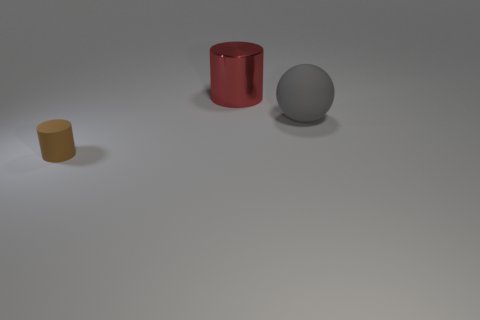Are there any other things that have the same size as the matte cylinder?
Ensure brevity in your answer.  No. There is a cylinder behind the matte cylinder; is its size the same as the tiny thing?
Ensure brevity in your answer.  No. There is a thing that is to the left of the large gray thing and right of the small brown thing; how big is it?
Provide a short and direct response. Large. How many other objects are the same material as the large gray object?
Your response must be concise. 1. There is a object that is behind the big matte sphere; what size is it?
Your answer should be compact. Large. How many big objects are either red cylinders or purple shiny objects?
Offer a very short reply. 1. Is there any other thing that has the same color as the rubber sphere?
Offer a very short reply. No. Are there any metallic objects behind the small matte thing?
Offer a terse response. Yes. How big is the thing in front of the rubber thing that is right of the brown thing?
Your response must be concise. Small. Is the number of rubber balls that are on the right side of the tiny brown matte cylinder the same as the number of large red metallic cylinders right of the gray thing?
Give a very brief answer. No. 